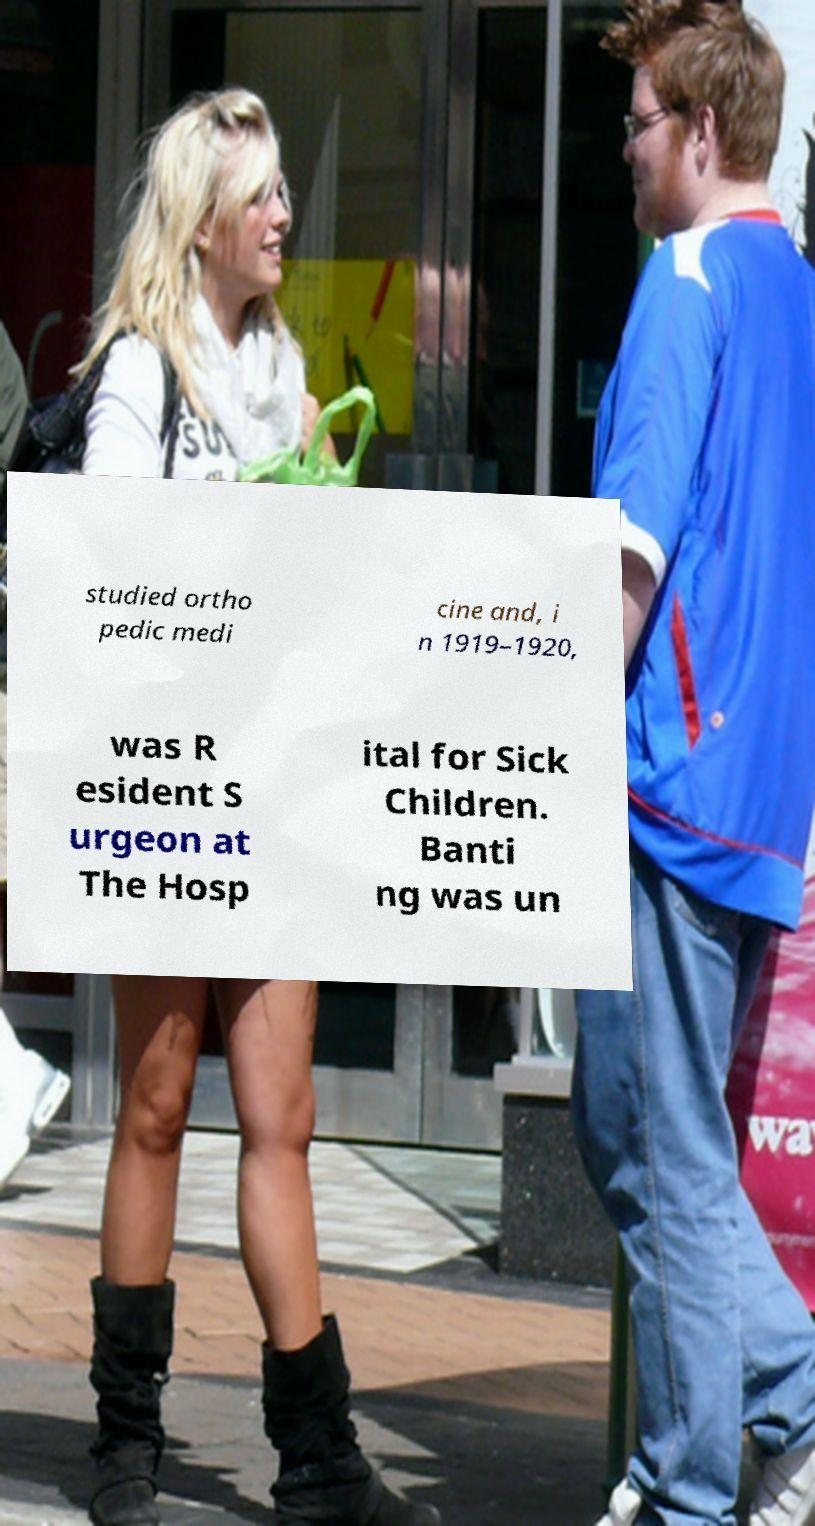Please read and relay the text visible in this image. What does it say? studied ortho pedic medi cine and, i n 1919–1920, was R esident S urgeon at The Hosp ital for Sick Children. Banti ng was un 